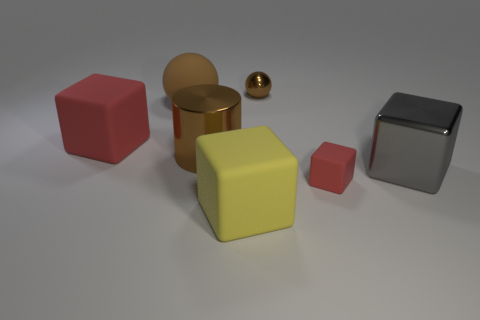What is the total number of objects presented in the image? The image showcases a total of six objects, consisting of various geometric shapes and colors. 